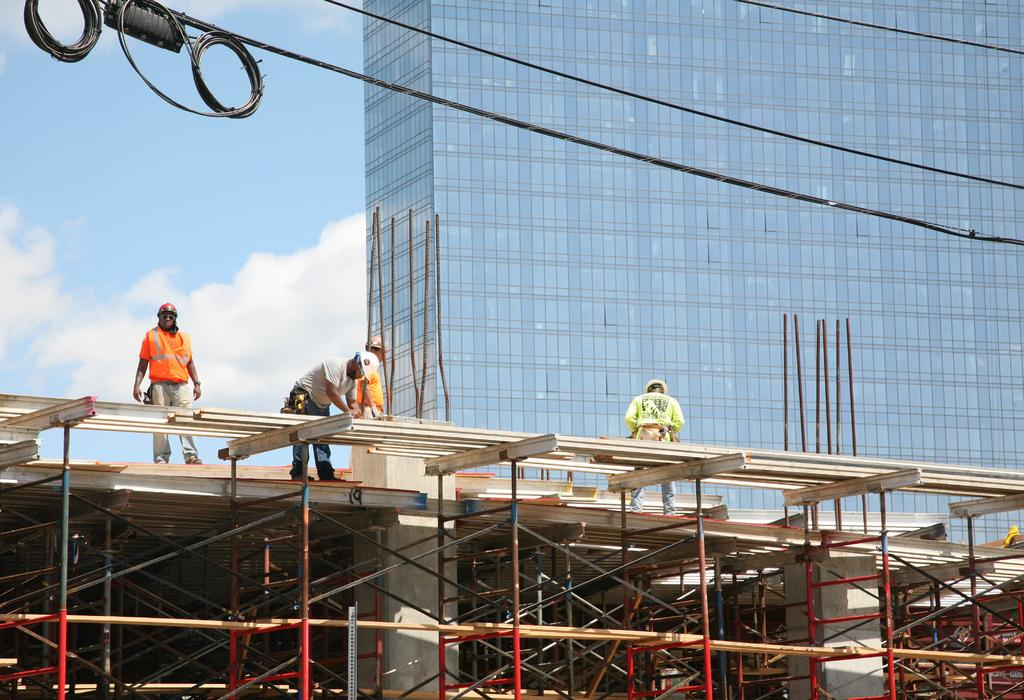What is the main structure in the image? There is a building in the image. What are the people on the building doing? The people are standing on the building. What can be seen on the heads of the people? The people are wearing caps on their heads. How would you describe the sky in the image? The sky is blue and cloudy. What type of sound can be heard coming from the people's mouths in the image? There is no indication of any sound or mouth activity in the image, as it only shows people standing on a building with caps on their heads. 